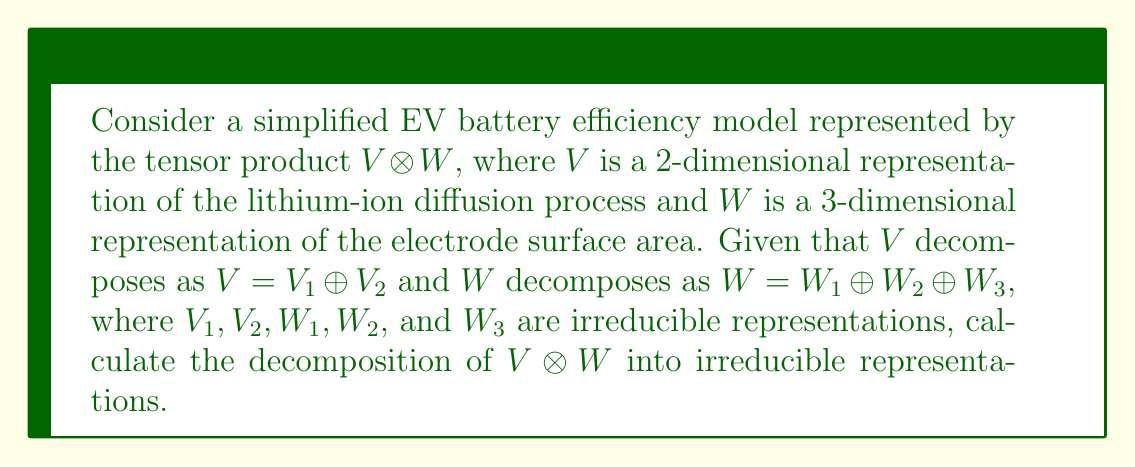Can you solve this math problem? To decompose the tensor product $V \otimes W$, we can follow these steps:

1) First, recall the distributive property of tensor products over direct sums:
   $$(A \oplus B) \otimes (C \oplus D) = (A \otimes C) \oplus (A \otimes D) \oplus (B \otimes C) \oplus (B \otimes D)$$

2) Apply this to our problem:
   $V \otimes W = (V_1 \oplus V_2) \otimes (W_1 \oplus W_2 \oplus W_3)$

3) Distribute the tensor product:
   $V \otimes W = (V_1 \otimes W_1) \oplus (V_1 \otimes W_2) \oplus (V_1 \otimes W_3) \oplus$
                 $(V_2 \otimes W_1) \oplus (V_2 \otimes W_2) \oplus (V_2 \otimes W_3)$

4) Each term $(V_i \otimes W_j)$ is a tensor product of irreducible representations. In general, these may not be irreducible, but for simplicity in this EV battery model, we'll assume they are.

5) Therefore, the decomposition of $V \otimes W$ into irreducible representations is the direct sum of six terms:
   $V \otimes W = (V_1 \otimes W_1) \oplus (V_1 \otimes W_2) \oplus (V_1 \otimes W_3) \oplus$
                 $(V_2 \otimes W_1) \oplus (V_2 \otimes W_2) \oplus (V_2 \otimes W_3)$

This decomposition represents different aspects of the battery efficiency model, combining lithium-ion diffusion processes with various electrode surface area characteristics.
Answer: $(V_1 \otimes W_1) \oplus (V_1 \otimes W_2) \oplus (V_1 \otimes W_3) \oplus (V_2 \otimes W_1) \oplus (V_2 \otimes W_2) \oplus (V_2 \otimes W_3)$ 